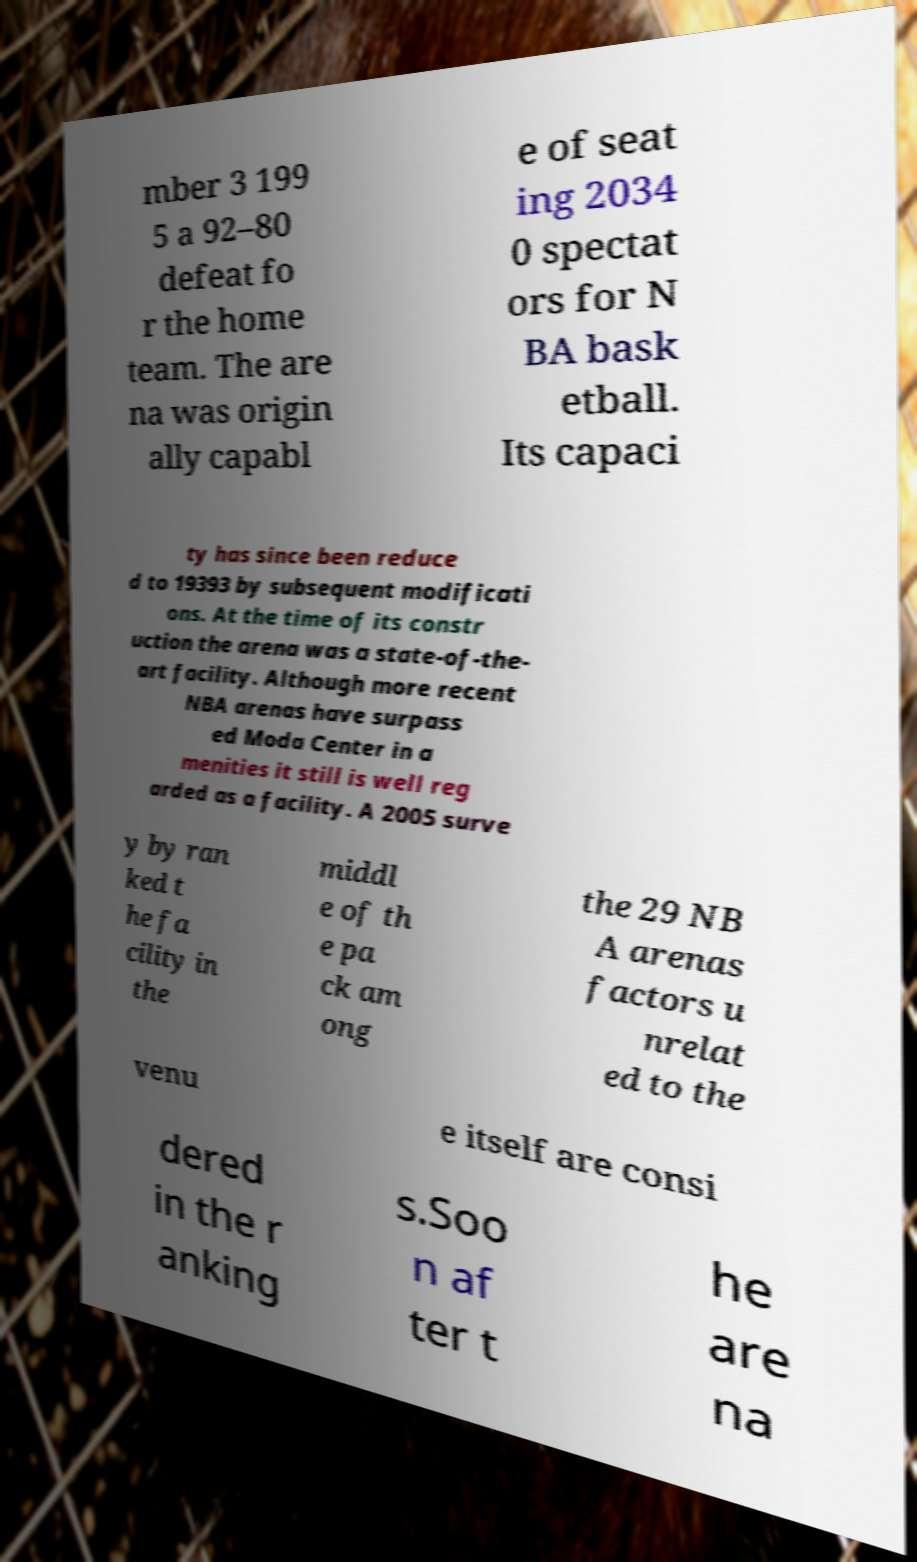Can you read and provide the text displayed in the image?This photo seems to have some interesting text. Can you extract and type it out for me? mber 3 199 5 a 92–80 defeat fo r the home team. The are na was origin ally capabl e of seat ing 2034 0 spectat ors for N BA bask etball. Its capaci ty has since been reduce d to 19393 by subsequent modificati ons. At the time of its constr uction the arena was a state-of-the- art facility. Although more recent NBA arenas have surpass ed Moda Center in a menities it still is well reg arded as a facility. A 2005 surve y by ran ked t he fa cility in the middl e of th e pa ck am ong the 29 NB A arenas factors u nrelat ed to the venu e itself are consi dered in the r anking s.Soo n af ter t he are na 